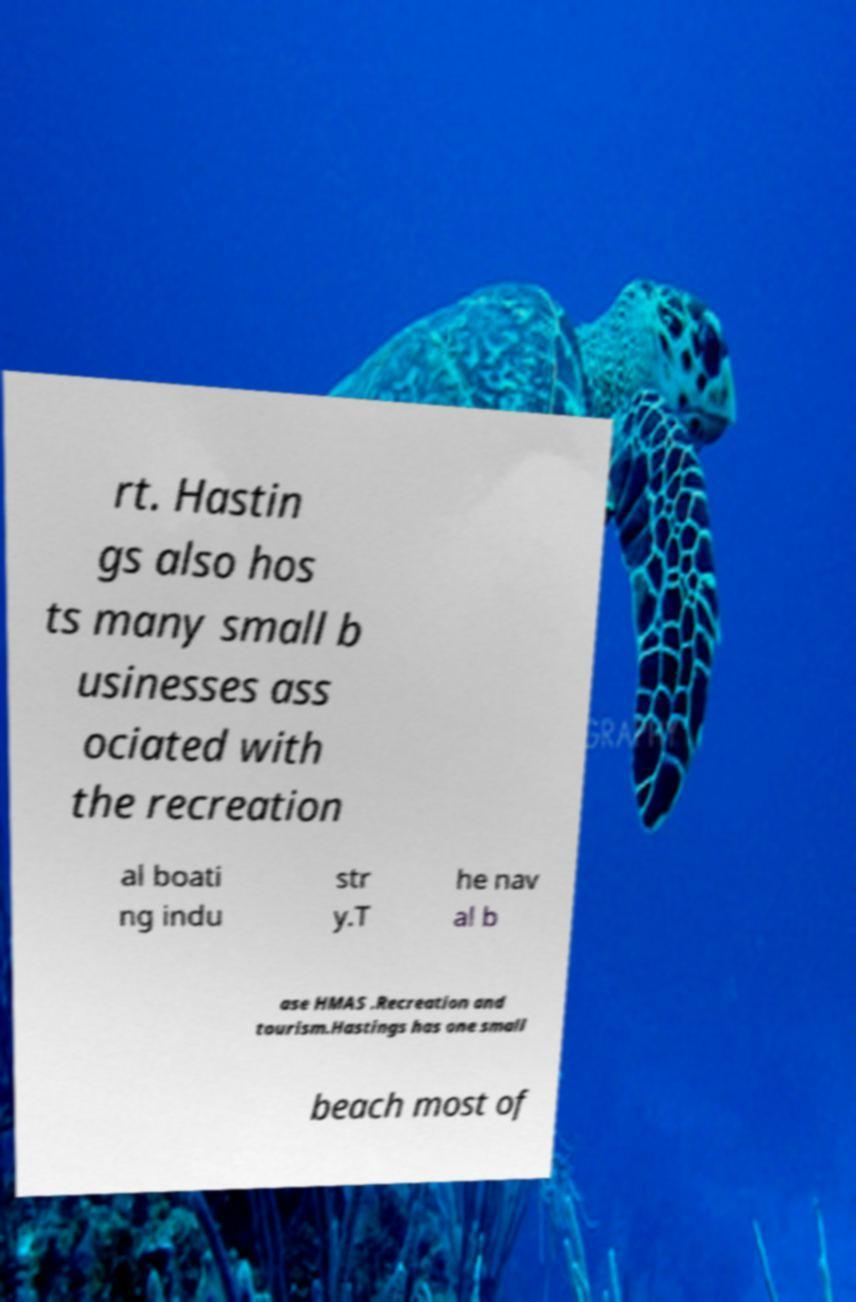Can you read and provide the text displayed in the image?This photo seems to have some interesting text. Can you extract and type it out for me? rt. Hastin gs also hos ts many small b usinesses ass ociated with the recreation al boati ng indu str y.T he nav al b ase HMAS .Recreation and tourism.Hastings has one small beach most of 